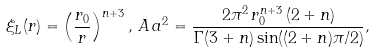<formula> <loc_0><loc_0><loc_500><loc_500>\xi _ { L } ( r ) = \left ( \frac { r _ { 0 } } { r } \right ) ^ { n + 3 } , \, A \, a ^ { 2 } = \frac { 2 \pi ^ { 2 } \, r _ { 0 } ^ { n + 3 } \, ( 2 + n ) } { \Gamma ( 3 + n ) \sin ( ( 2 + n ) \pi / 2 ) } ,</formula> 